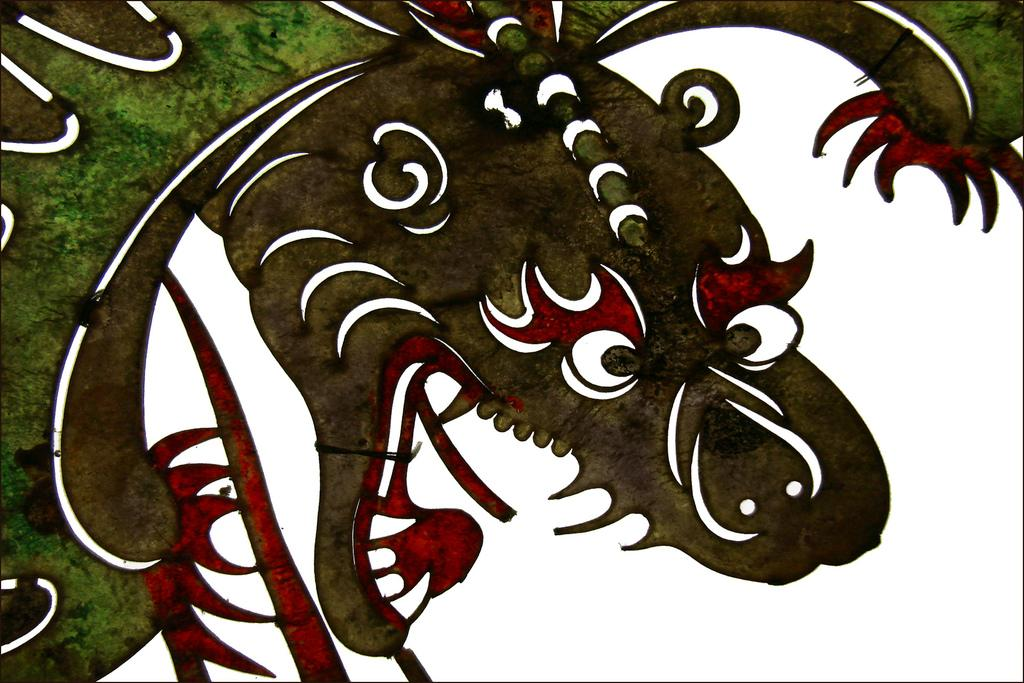What is depicted in the image? There is an art of a dragon in the image. What colors are present in the dragon? The dragon has white, green, brown, and red colors. In which area of the image does the dragon appear to be white? The dragon appears to be white in a specific area of the image. What type of bottle is the girl holding in the image? There is no girl or bottle present in the image; it only features an art of a dragon. 